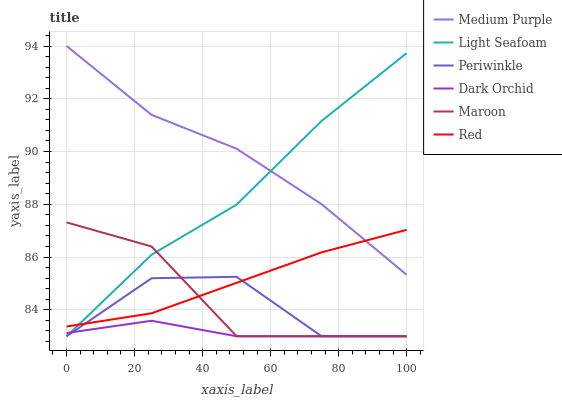Does Dark Orchid have the minimum area under the curve?
Answer yes or no. Yes. Does Medium Purple have the maximum area under the curve?
Answer yes or no. Yes. Does Periwinkle have the minimum area under the curve?
Answer yes or no. No. Does Periwinkle have the maximum area under the curve?
Answer yes or no. No. Is Red the smoothest?
Answer yes or no. Yes. Is Periwinkle the roughest?
Answer yes or no. Yes. Is Medium Purple the smoothest?
Answer yes or no. No. Is Medium Purple the roughest?
Answer yes or no. No. Does Maroon have the lowest value?
Answer yes or no. Yes. Does Medium Purple have the lowest value?
Answer yes or no. No. Does Medium Purple have the highest value?
Answer yes or no. Yes. Does Periwinkle have the highest value?
Answer yes or no. No. Is Maroon less than Medium Purple?
Answer yes or no. Yes. Is Red greater than Dark Orchid?
Answer yes or no. Yes. Does Periwinkle intersect Red?
Answer yes or no. Yes. Is Periwinkle less than Red?
Answer yes or no. No. Is Periwinkle greater than Red?
Answer yes or no. No. Does Maroon intersect Medium Purple?
Answer yes or no. No. 